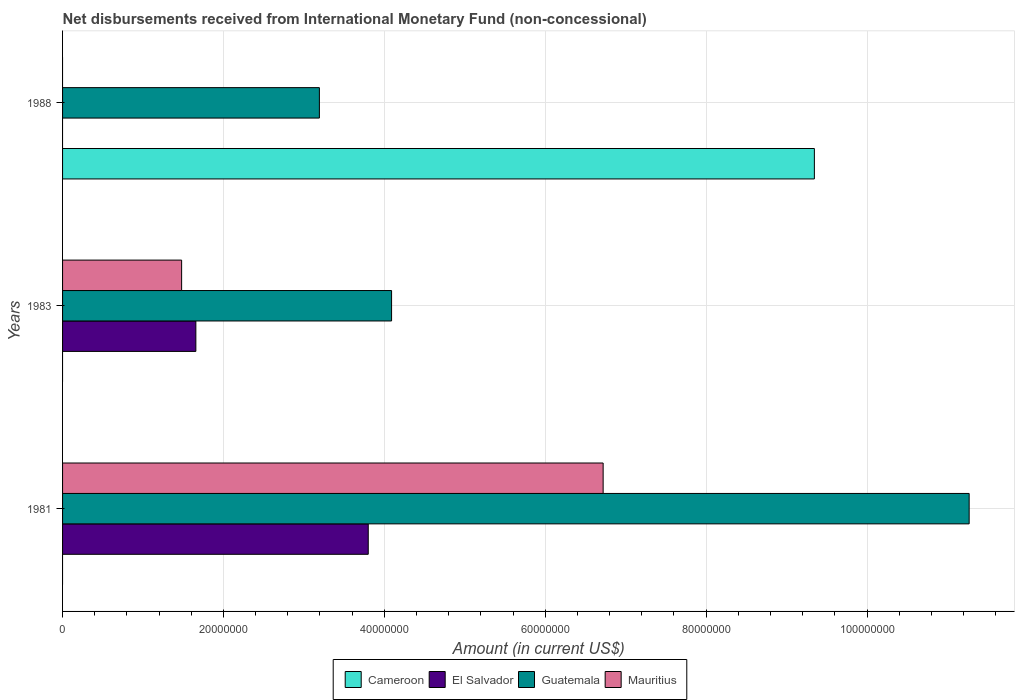How many different coloured bars are there?
Keep it short and to the point. 4. How many groups of bars are there?
Make the answer very short. 3. How many bars are there on the 2nd tick from the top?
Ensure brevity in your answer.  3. What is the label of the 2nd group of bars from the top?
Give a very brief answer. 1983. What is the amount of disbursements received from International Monetary Fund in El Salvador in 1983?
Your answer should be compact. 1.66e+07. Across all years, what is the maximum amount of disbursements received from International Monetary Fund in Cameroon?
Provide a short and direct response. 9.35e+07. In which year was the amount of disbursements received from International Monetary Fund in El Salvador maximum?
Provide a short and direct response. 1981. What is the total amount of disbursements received from International Monetary Fund in Mauritius in the graph?
Make the answer very short. 8.20e+07. What is the difference between the amount of disbursements received from International Monetary Fund in Mauritius in 1981 and that in 1983?
Provide a succinct answer. 5.24e+07. What is the difference between the amount of disbursements received from International Monetary Fund in Cameroon in 1981 and the amount of disbursements received from International Monetary Fund in El Salvador in 1983?
Offer a very short reply. -1.66e+07. What is the average amount of disbursements received from International Monetary Fund in Mauritius per year?
Keep it short and to the point. 2.73e+07. In the year 1981, what is the difference between the amount of disbursements received from International Monetary Fund in Guatemala and amount of disbursements received from International Monetary Fund in Mauritius?
Provide a short and direct response. 4.55e+07. In how many years, is the amount of disbursements received from International Monetary Fund in Cameroon greater than 68000000 US$?
Offer a terse response. 1. What is the ratio of the amount of disbursements received from International Monetary Fund in Guatemala in 1983 to that in 1988?
Your answer should be compact. 1.28. What is the difference between the highest and the second highest amount of disbursements received from International Monetary Fund in Guatemala?
Keep it short and to the point. 7.18e+07. What is the difference between the highest and the lowest amount of disbursements received from International Monetary Fund in El Salvador?
Provide a succinct answer. 3.80e+07. In how many years, is the amount of disbursements received from International Monetary Fund in El Salvador greater than the average amount of disbursements received from International Monetary Fund in El Salvador taken over all years?
Keep it short and to the point. 1. Is it the case that in every year, the sum of the amount of disbursements received from International Monetary Fund in Mauritius and amount of disbursements received from International Monetary Fund in El Salvador is greater than the amount of disbursements received from International Monetary Fund in Guatemala?
Give a very brief answer. No. How many bars are there?
Offer a terse response. 8. How many years are there in the graph?
Offer a very short reply. 3. Are the values on the major ticks of X-axis written in scientific E-notation?
Provide a succinct answer. No. Does the graph contain any zero values?
Give a very brief answer. Yes. Does the graph contain grids?
Keep it short and to the point. Yes. Where does the legend appear in the graph?
Offer a very short reply. Bottom center. How many legend labels are there?
Provide a short and direct response. 4. How are the legend labels stacked?
Give a very brief answer. Horizontal. What is the title of the graph?
Your answer should be very brief. Net disbursements received from International Monetary Fund (non-concessional). What is the label or title of the X-axis?
Provide a succinct answer. Amount (in current US$). What is the label or title of the Y-axis?
Keep it short and to the point. Years. What is the Amount (in current US$) in Cameroon in 1981?
Your answer should be compact. 0. What is the Amount (in current US$) in El Salvador in 1981?
Offer a very short reply. 3.80e+07. What is the Amount (in current US$) of Guatemala in 1981?
Offer a terse response. 1.13e+08. What is the Amount (in current US$) of Mauritius in 1981?
Keep it short and to the point. 6.72e+07. What is the Amount (in current US$) in Cameroon in 1983?
Ensure brevity in your answer.  0. What is the Amount (in current US$) in El Salvador in 1983?
Make the answer very short. 1.66e+07. What is the Amount (in current US$) in Guatemala in 1983?
Provide a succinct answer. 4.09e+07. What is the Amount (in current US$) of Mauritius in 1983?
Your answer should be very brief. 1.48e+07. What is the Amount (in current US$) in Cameroon in 1988?
Provide a short and direct response. 9.35e+07. What is the Amount (in current US$) in Guatemala in 1988?
Your response must be concise. 3.19e+07. Across all years, what is the maximum Amount (in current US$) of Cameroon?
Provide a short and direct response. 9.35e+07. Across all years, what is the maximum Amount (in current US$) in El Salvador?
Provide a short and direct response. 3.80e+07. Across all years, what is the maximum Amount (in current US$) of Guatemala?
Make the answer very short. 1.13e+08. Across all years, what is the maximum Amount (in current US$) in Mauritius?
Provide a short and direct response. 6.72e+07. Across all years, what is the minimum Amount (in current US$) in Cameroon?
Provide a short and direct response. 0. Across all years, what is the minimum Amount (in current US$) in Guatemala?
Your answer should be compact. 3.19e+07. Across all years, what is the minimum Amount (in current US$) of Mauritius?
Your answer should be compact. 0. What is the total Amount (in current US$) in Cameroon in the graph?
Provide a short and direct response. 9.35e+07. What is the total Amount (in current US$) of El Salvador in the graph?
Keep it short and to the point. 5.46e+07. What is the total Amount (in current US$) in Guatemala in the graph?
Keep it short and to the point. 1.86e+08. What is the total Amount (in current US$) in Mauritius in the graph?
Ensure brevity in your answer.  8.20e+07. What is the difference between the Amount (in current US$) of El Salvador in 1981 and that in 1983?
Offer a very short reply. 2.14e+07. What is the difference between the Amount (in current US$) of Guatemala in 1981 and that in 1983?
Give a very brief answer. 7.18e+07. What is the difference between the Amount (in current US$) in Mauritius in 1981 and that in 1983?
Provide a short and direct response. 5.24e+07. What is the difference between the Amount (in current US$) in Guatemala in 1981 and that in 1988?
Make the answer very short. 8.08e+07. What is the difference between the Amount (in current US$) of Guatemala in 1983 and that in 1988?
Make the answer very short. 8.97e+06. What is the difference between the Amount (in current US$) of El Salvador in 1981 and the Amount (in current US$) of Guatemala in 1983?
Your answer should be compact. -2.90e+06. What is the difference between the Amount (in current US$) of El Salvador in 1981 and the Amount (in current US$) of Mauritius in 1983?
Give a very brief answer. 2.32e+07. What is the difference between the Amount (in current US$) of Guatemala in 1981 and the Amount (in current US$) of Mauritius in 1983?
Give a very brief answer. 9.79e+07. What is the difference between the Amount (in current US$) in El Salvador in 1981 and the Amount (in current US$) in Guatemala in 1988?
Ensure brevity in your answer.  6.07e+06. What is the difference between the Amount (in current US$) in El Salvador in 1983 and the Amount (in current US$) in Guatemala in 1988?
Your response must be concise. -1.54e+07. What is the average Amount (in current US$) of Cameroon per year?
Your answer should be very brief. 3.12e+07. What is the average Amount (in current US$) in El Salvador per year?
Provide a succinct answer. 1.82e+07. What is the average Amount (in current US$) in Guatemala per year?
Provide a short and direct response. 6.18e+07. What is the average Amount (in current US$) of Mauritius per year?
Your answer should be very brief. 2.73e+07. In the year 1981, what is the difference between the Amount (in current US$) of El Salvador and Amount (in current US$) of Guatemala?
Give a very brief answer. -7.47e+07. In the year 1981, what is the difference between the Amount (in current US$) of El Salvador and Amount (in current US$) of Mauritius?
Keep it short and to the point. -2.92e+07. In the year 1981, what is the difference between the Amount (in current US$) of Guatemala and Amount (in current US$) of Mauritius?
Give a very brief answer. 4.55e+07. In the year 1983, what is the difference between the Amount (in current US$) of El Salvador and Amount (in current US$) of Guatemala?
Keep it short and to the point. -2.43e+07. In the year 1983, what is the difference between the Amount (in current US$) in El Salvador and Amount (in current US$) in Mauritius?
Ensure brevity in your answer.  1.77e+06. In the year 1983, what is the difference between the Amount (in current US$) in Guatemala and Amount (in current US$) in Mauritius?
Your response must be concise. 2.61e+07. In the year 1988, what is the difference between the Amount (in current US$) in Cameroon and Amount (in current US$) in Guatemala?
Offer a very short reply. 6.15e+07. What is the ratio of the Amount (in current US$) of El Salvador in 1981 to that in 1983?
Your answer should be very brief. 2.29. What is the ratio of the Amount (in current US$) of Guatemala in 1981 to that in 1983?
Keep it short and to the point. 2.76. What is the ratio of the Amount (in current US$) of Mauritius in 1981 to that in 1983?
Your response must be concise. 4.54. What is the ratio of the Amount (in current US$) of Guatemala in 1981 to that in 1988?
Ensure brevity in your answer.  3.53. What is the ratio of the Amount (in current US$) of Guatemala in 1983 to that in 1988?
Offer a very short reply. 1.28. What is the difference between the highest and the second highest Amount (in current US$) in Guatemala?
Offer a very short reply. 7.18e+07. What is the difference between the highest and the lowest Amount (in current US$) of Cameroon?
Provide a short and direct response. 9.35e+07. What is the difference between the highest and the lowest Amount (in current US$) of El Salvador?
Provide a short and direct response. 3.80e+07. What is the difference between the highest and the lowest Amount (in current US$) in Guatemala?
Give a very brief answer. 8.08e+07. What is the difference between the highest and the lowest Amount (in current US$) in Mauritius?
Give a very brief answer. 6.72e+07. 